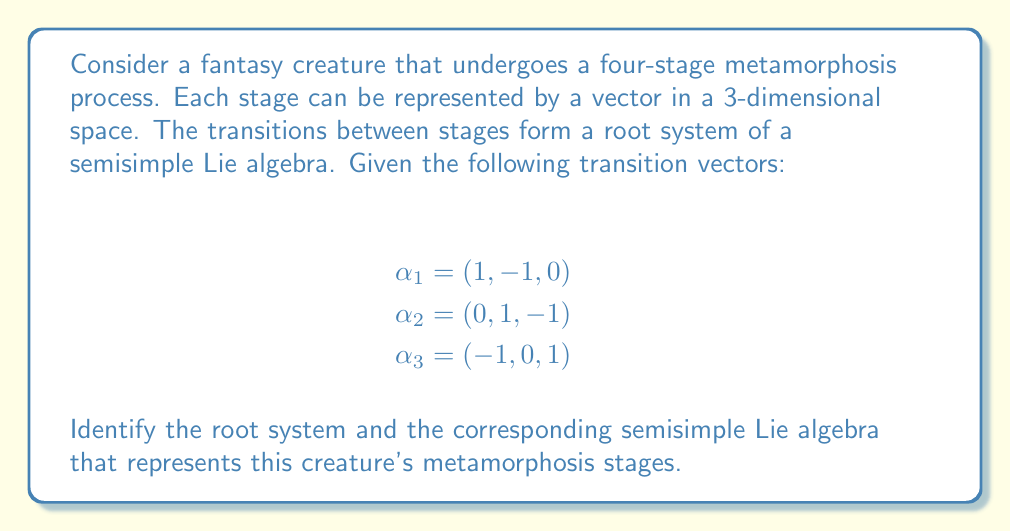Show me your answer to this math problem. To identify the root system and the corresponding semisimple Lie algebra, we need to analyze the given transition vectors and their properties:

1. First, we observe that we have three simple roots: $\alpha_1$, $\alpha_2$, and $\alpha_3$.

2. We can calculate the Cartan matrix using the formula:
   $$A_{ij} = \frac{2(\alpha_i, \alpha_j)}{(\alpha_j, \alpha_j)}$$
   where $(\alpha_i, \alpha_j)$ denotes the inner product of the roots.

3. Calculating the inner products:
   $(\alpha_1, \alpha_1) = (\alpha_2, \alpha_2) = (\alpha_3, \alpha_3) = 2$
   $(\alpha_1, \alpha_2) = (\alpha_2, \alpha_3) = -1$
   $(\alpha_1, \alpha_3) = 0$

4. Now we can construct the Cartan matrix:
   $$A = \begin{pmatrix}
   2 & -1 & 0 \\
   -1 & 2 & -1 \\
   0 & -1 & 2
   \end{pmatrix}$$

5. This Cartan matrix corresponds to the Dynkin diagram:

   [asy]
   unitsize(1cm);
   dot((0,0)); dot((1,0)); dot((2,0));
   draw((0,0)--(2,0));
   label("$\alpha_1$", (0,0), S);
   label("$\alpha_2$", (1,0), S);
   label("$\alpha_3$", (2,0), S);
   [/asy]

6. The Dynkin diagram and Cartan matrix we obtained correspond to the root system of type $A_3$.

7. The semisimple Lie algebra associated with the root system $A_3$ is $\mathfrak{sl}(4, \mathbb{C})$, which is the special linear Lie algebra of $4 \times 4$ complex matrices with trace zero.

Therefore, the creature's four-stage metamorphosis process can be represented by the root system $A_3$ and the corresponding semisimple Lie algebra $\mathfrak{sl}(4, \mathbb{C})$.
Answer: The root system is $A_3$, and the corresponding semisimple Lie algebra is $\mathfrak{sl}(4, \mathbb{C})$. 